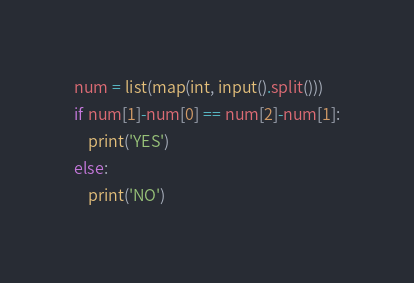Convert code to text. <code><loc_0><loc_0><loc_500><loc_500><_Python_>num = list(map(int, input().split()))
if num[1]-num[0] == num[2]-num[1]:
	print('YES')
else:
	print('NO')
</code> 